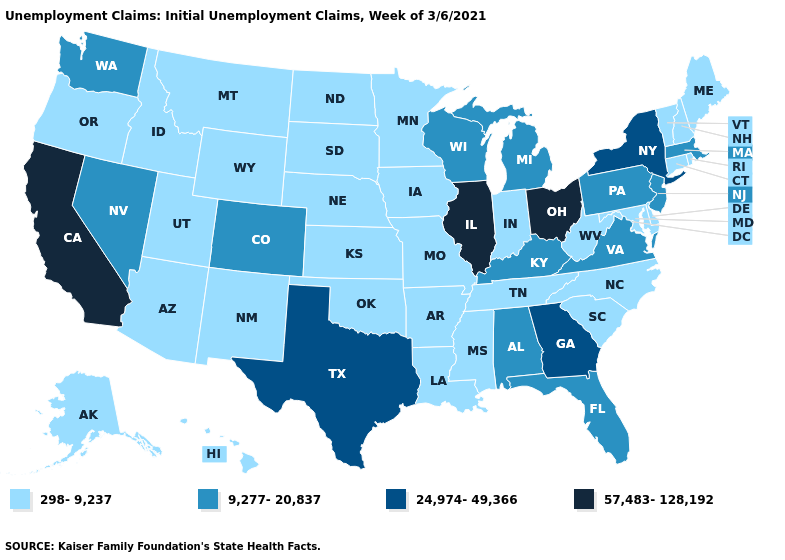Does Illinois have the highest value in the MidWest?
Keep it brief. Yes. What is the highest value in the USA?
Keep it brief. 57,483-128,192. Name the states that have a value in the range 57,483-128,192?
Answer briefly. California, Illinois, Ohio. Does Iowa have a higher value than Oklahoma?
Short answer required. No. What is the lowest value in the West?
Concise answer only. 298-9,237. Name the states that have a value in the range 9,277-20,837?
Quick response, please. Alabama, Colorado, Florida, Kentucky, Massachusetts, Michigan, Nevada, New Jersey, Pennsylvania, Virginia, Washington, Wisconsin. Does the first symbol in the legend represent the smallest category?
Write a very short answer. Yes. What is the lowest value in the West?
Write a very short answer. 298-9,237. Does Nevada have a higher value than Vermont?
Concise answer only. Yes. What is the value of California?
Be succinct. 57,483-128,192. What is the value of Tennessee?
Write a very short answer. 298-9,237. What is the highest value in the MidWest ?
Short answer required. 57,483-128,192. What is the value of Oregon?
Concise answer only. 298-9,237. What is the highest value in the USA?
Write a very short answer. 57,483-128,192. 